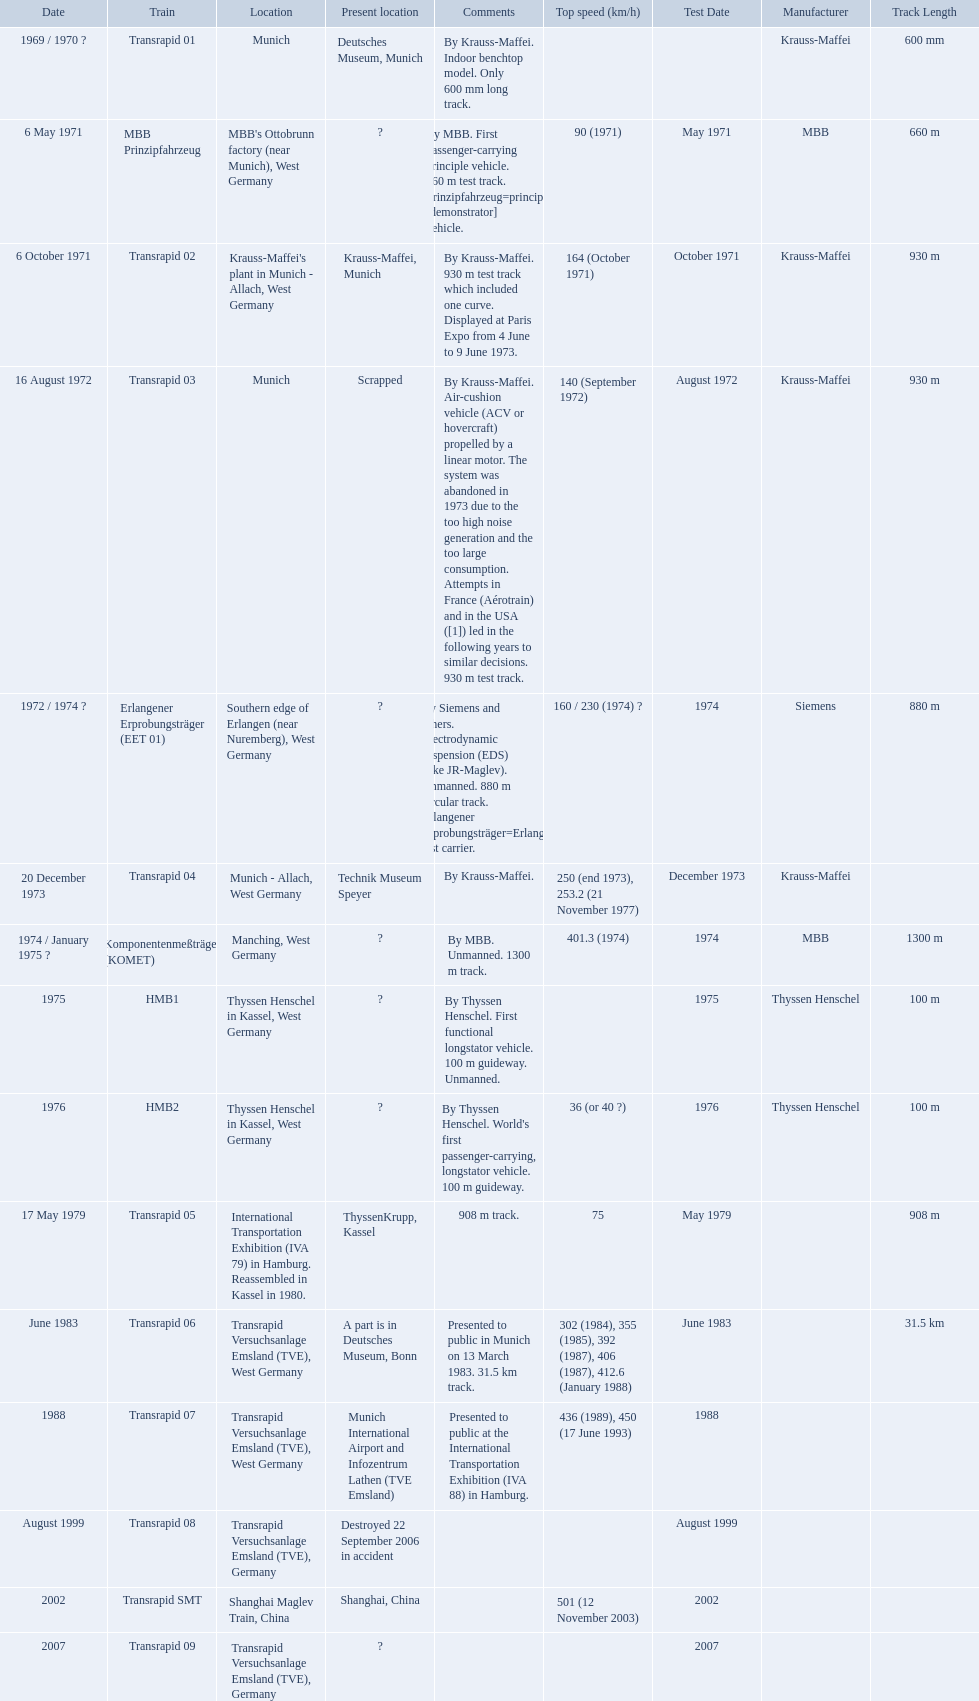What is the top speed reached by any trains shown here? 501 (12 November 2003). What train has reached a top speed of 501? Transrapid SMT. What are the names of each transrapid train? Transrapid 01, MBB Prinzipfahrzeug, Transrapid 02, Transrapid 03, Erlangener Erprobungsträger (EET 01), Transrapid 04, Komponentenmeßträger (KOMET), HMB1, HMB2, Transrapid 05, Transrapid 06, Transrapid 07, Transrapid 08, Transrapid SMT, Transrapid 09. What are their listed top speeds? 90 (1971), 164 (October 1971), 140 (September 1972), 160 / 230 (1974) ?, 250 (end 1973), 253.2 (21 November 1977), 401.3 (1974), 36 (or 40 ?), 75, 302 (1984), 355 (1985), 392 (1987), 406 (1987), 412.6 (January 1988), 436 (1989), 450 (17 June 1993), 501 (12 November 2003). And which train operates at the fastest speed? Transrapid SMT. 